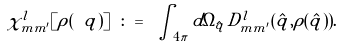Convert formula to latex. <formula><loc_0><loc_0><loc_500><loc_500>\chi ^ { l } _ { m m ^ { \prime } } [ \rho ( \ q ) ] \ \colon = \ \int _ { 4 \pi } d \Omega _ { \hat { q } } \, D ^ { l } _ { m m ^ { \prime } } ( \hat { q } , \rho ( \hat { q } ) ) .</formula> 